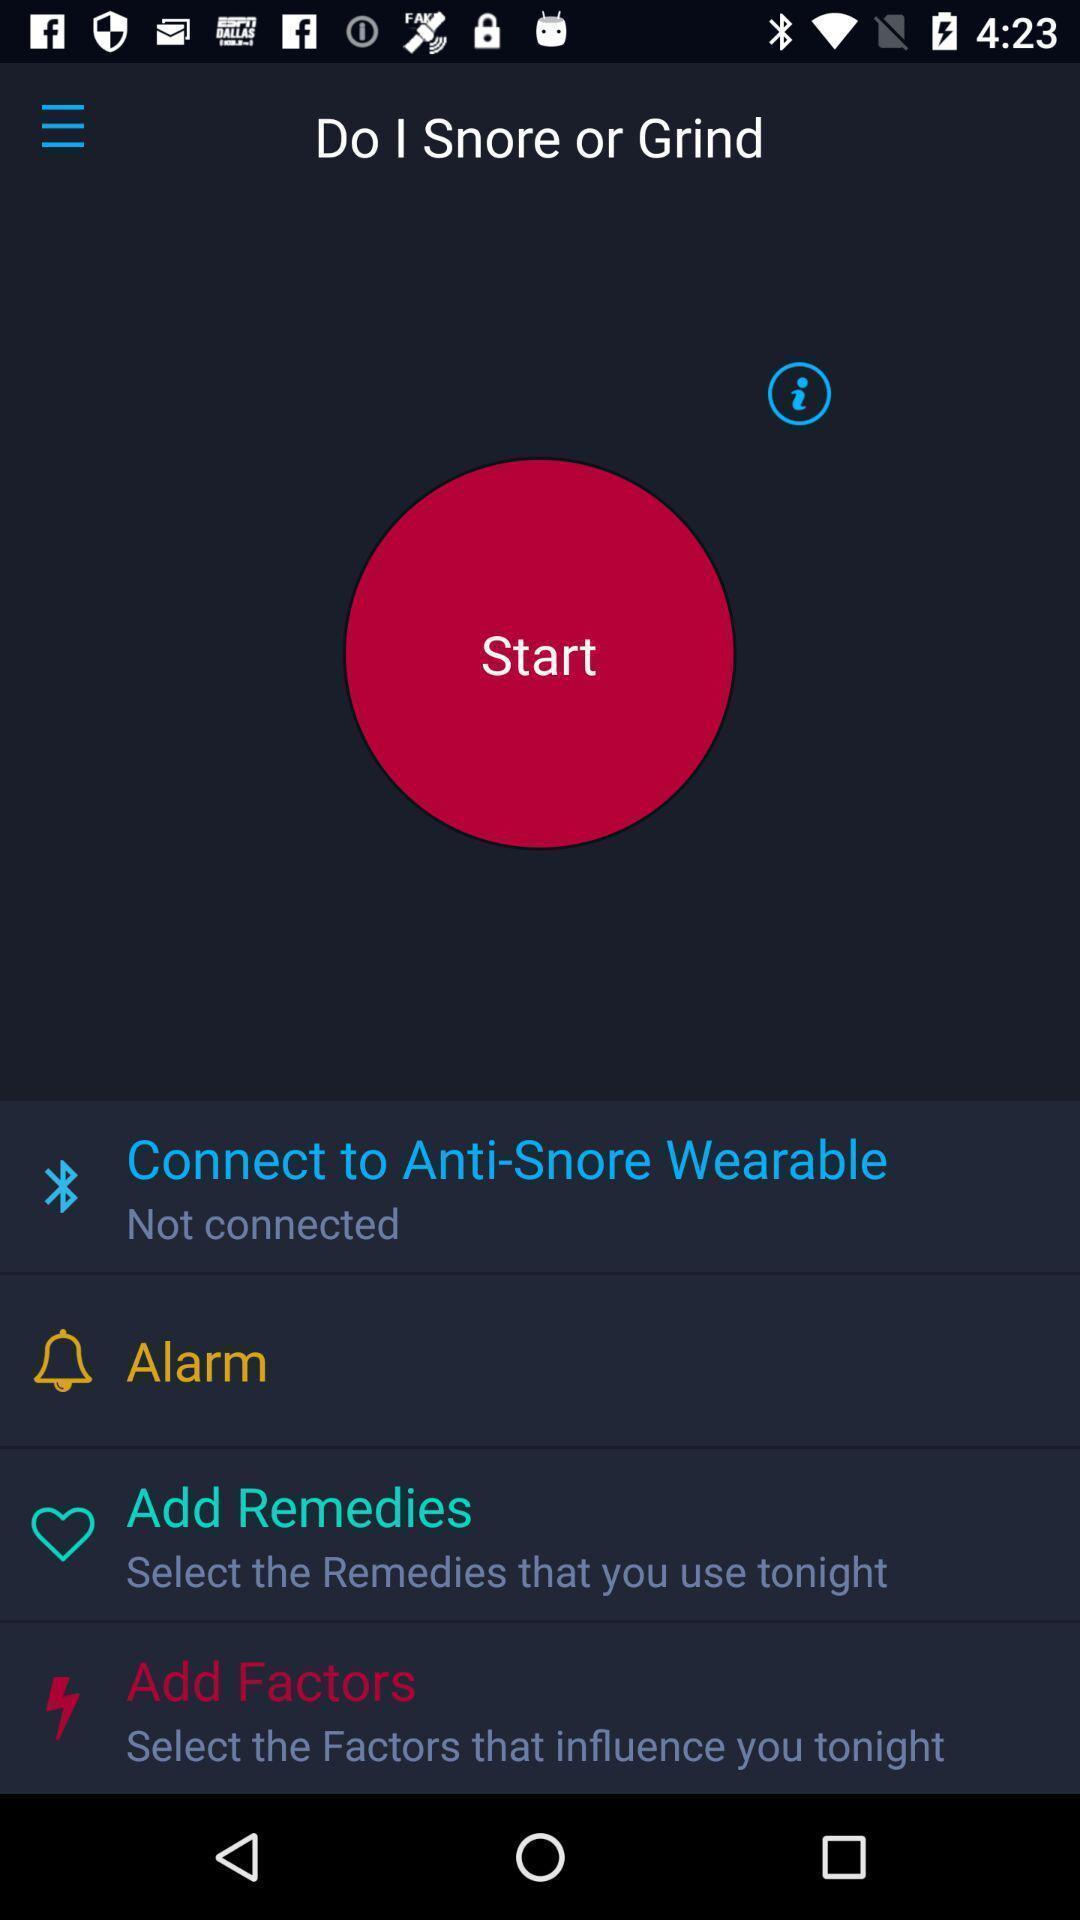Give me a narrative description of this picture. Start page. 